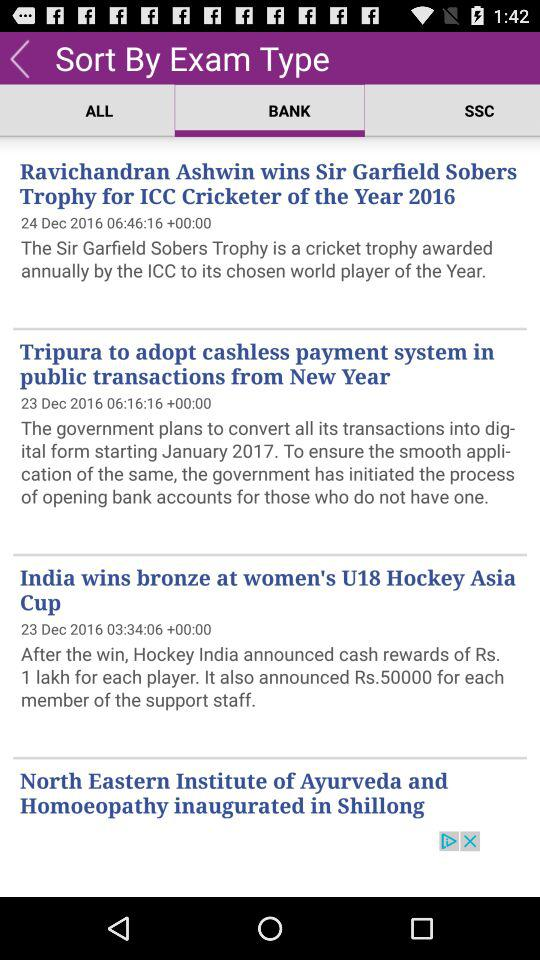How much price is announced by Hockey India for each member of the support staff? The price is Rs. 50000. 